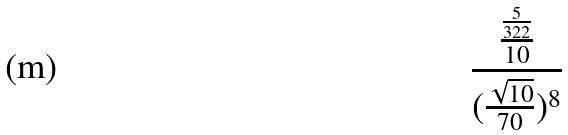Convert formula to latex. <formula><loc_0><loc_0><loc_500><loc_500>\frac { \frac { \frac { 5 } { 3 2 2 } } { 1 0 } } { ( \frac { \sqrt { 1 0 } } { 7 0 } ) ^ { 8 } }</formula> 